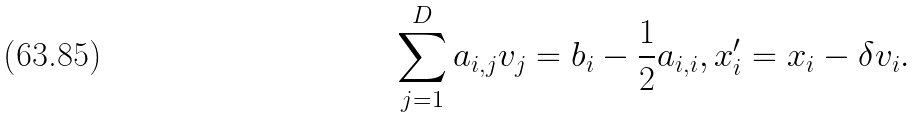Convert formula to latex. <formula><loc_0><loc_0><loc_500><loc_500>\sum _ { j = 1 } ^ { D } a _ { i , j } v _ { j } = b _ { i } - \frac { 1 } { 2 } a _ { i , i } , x _ { i } ^ { \prime } = x _ { i } - \delta v _ { i } .</formula> 